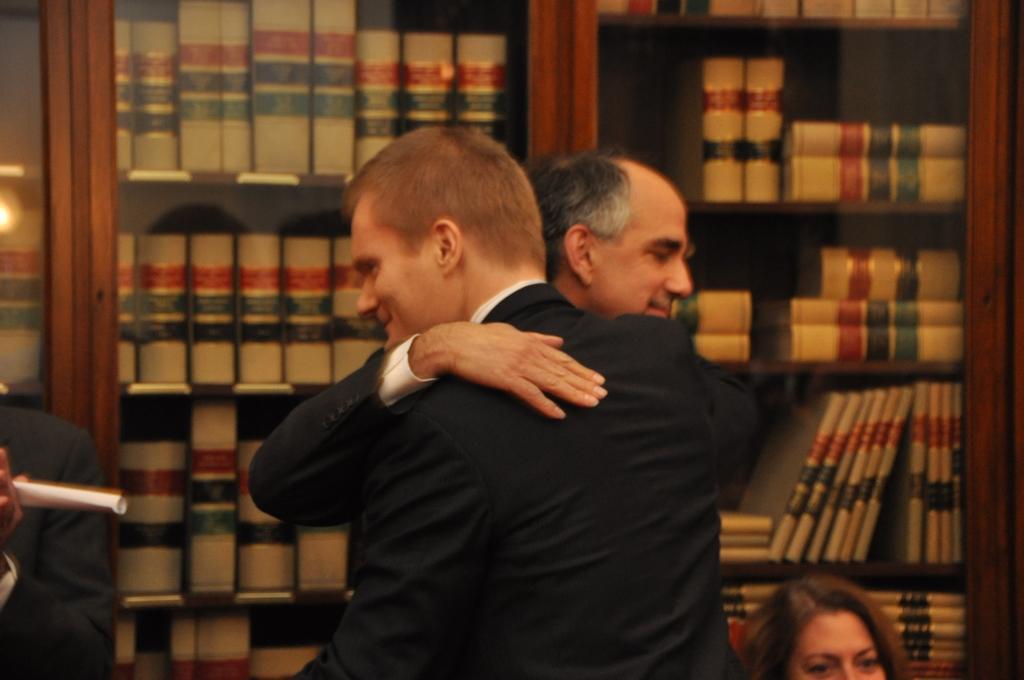Describe this image in one or two sentences. This image is taken indoors. In the background there are a few racks with shells and there are many books on a shelves. On the left side of the image there is a person and holding a paper in the hands. In the middle of the image two men are standing and they are hugging each other and there is a woman. 